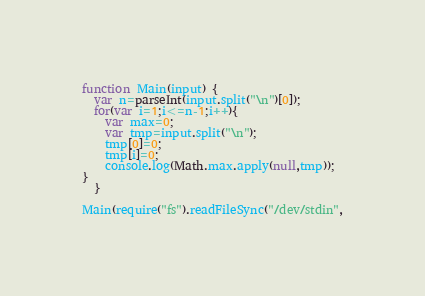<code> <loc_0><loc_0><loc_500><loc_500><_JavaScript_>function Main(input) {
  var n=parseInt(input.split("\n")[0]);
  for(var i=1;i<=n-1;i++){
    var max=0;
    var tmp=input.split("\n");
    tmp[0]=0;
    tmp[i]=0;
    console.log(Math.max.apply(null,tmp));
}
  }

Main(require("fs").readFileSync("/dev/stdin",</code> 